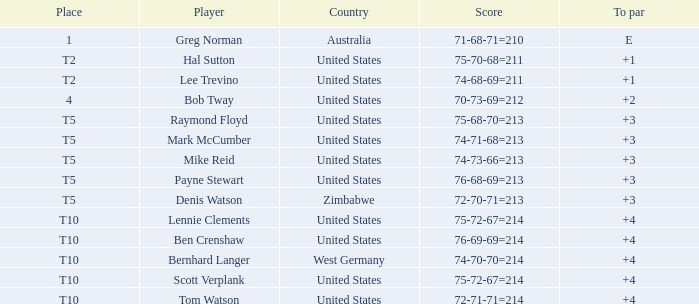What is the place of Australia? 1.0. 